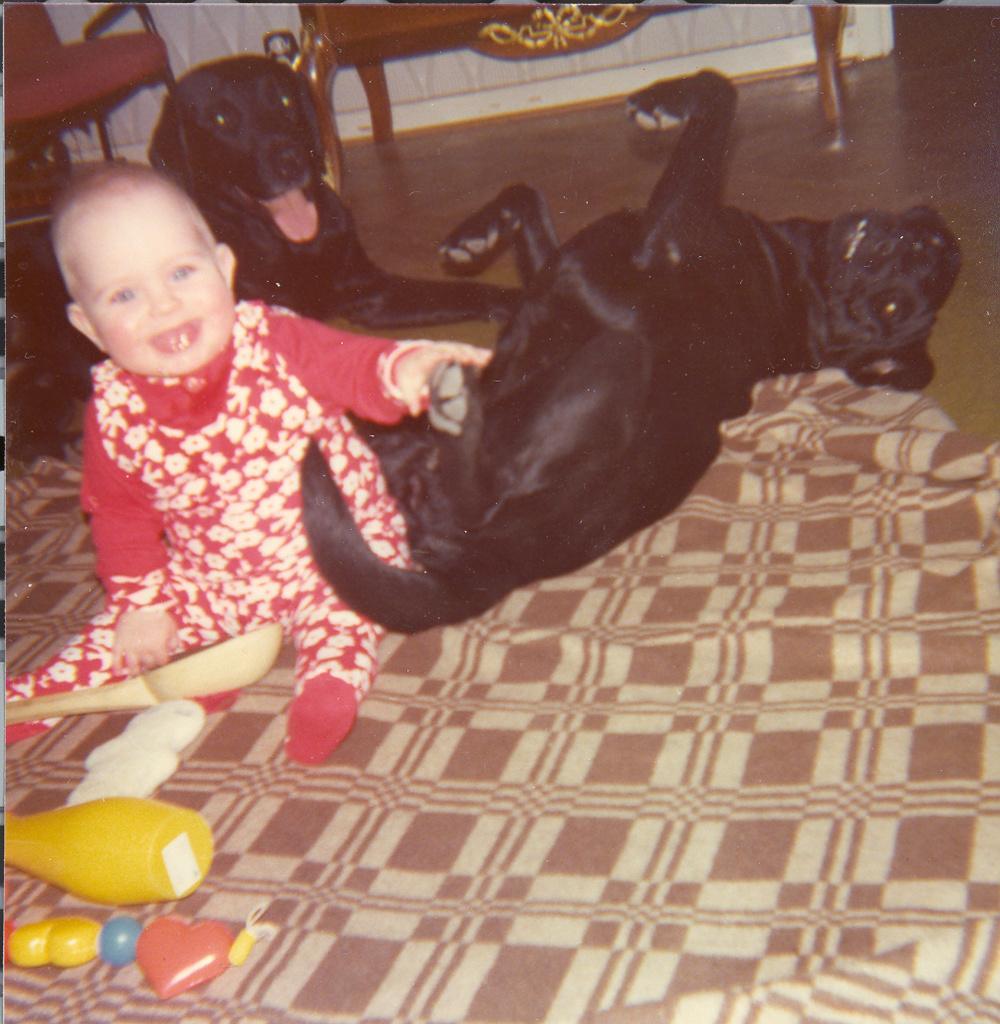Could you give a brief overview of what you see in this image? In the picture I can see a child and two black color dogs on the floor. I can also see a cloth, a chair, toys and some other objects. 